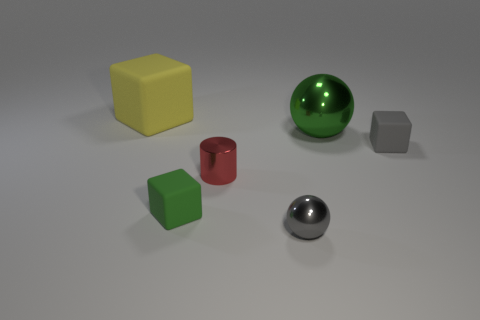Add 1 large purple metallic cubes. How many objects exist? 7 Subtract all cylinders. How many objects are left? 5 Subtract all metallic cylinders. Subtract all gray matte cubes. How many objects are left? 4 Add 1 large rubber things. How many large rubber things are left? 2 Add 2 brown matte cylinders. How many brown matte cylinders exist? 2 Subtract 0 blue cubes. How many objects are left? 6 